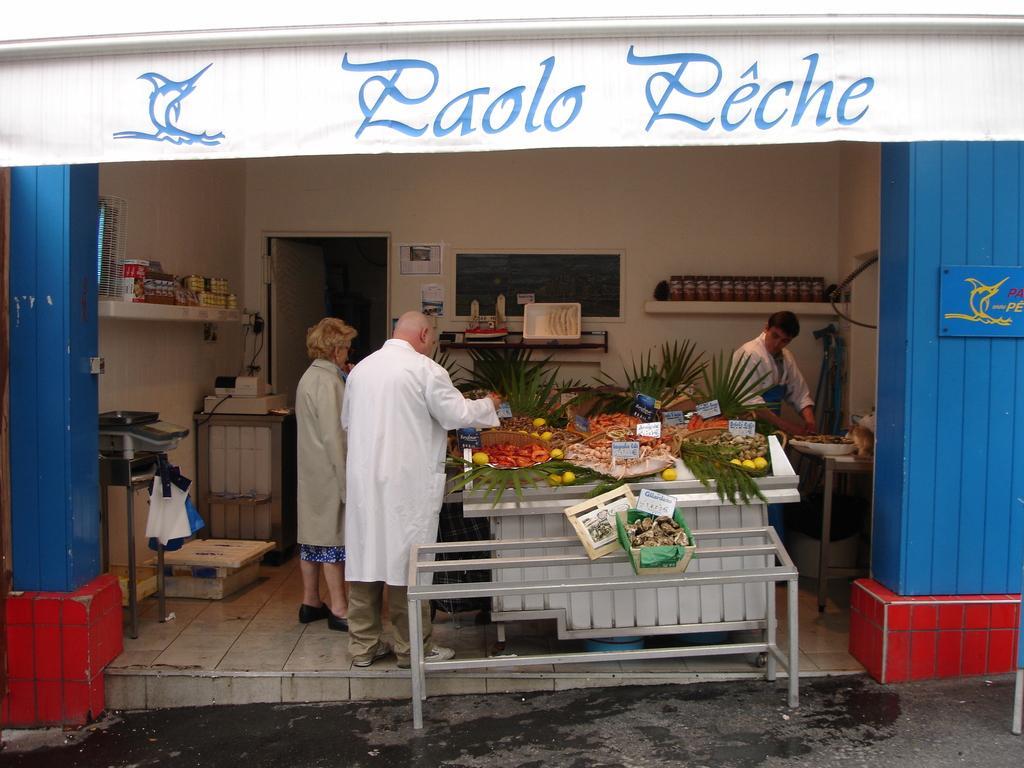Please provide a concise description of this image. In this image I can see few people are standing, here on this table I can see vegetables. 